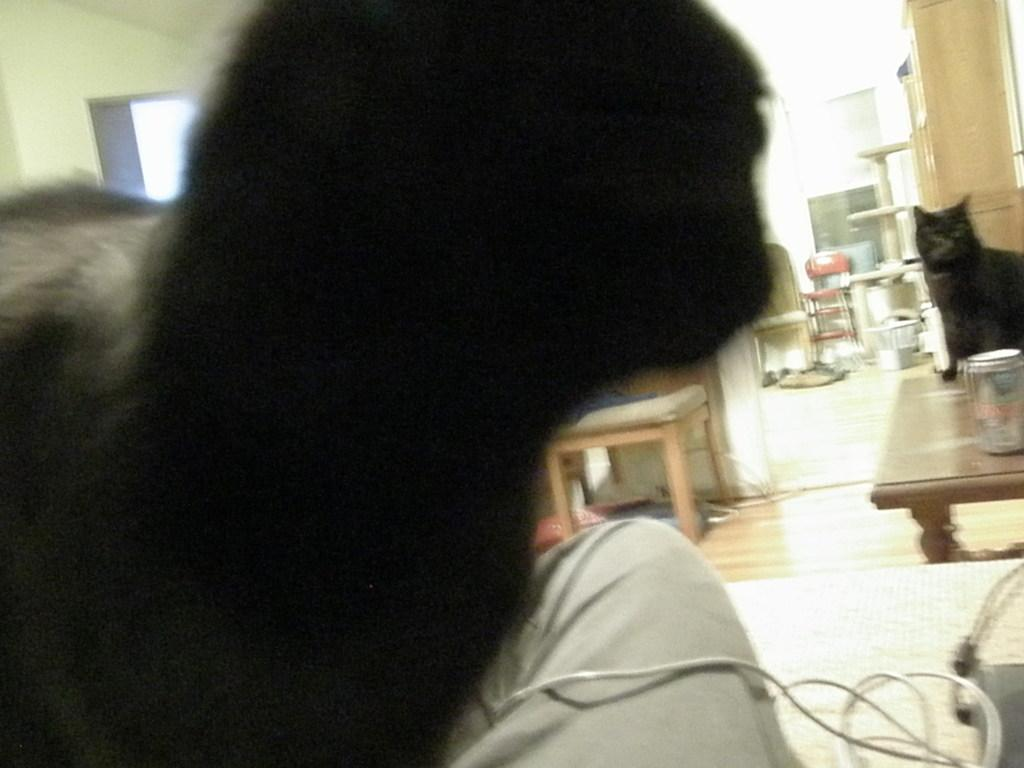What is on the floor in the image? There is a table on the floor in the image. What is on the table? There is a cat and a tin on the table. What can be seen in the background of the image? There is a chair in the background. Are there any objects near the table? Yes, there are objects on the table or nearby. What is visible on the wall in the image? There is a wall visible in the image. Can you describe the person in the image? There is a person with hair in the image. What type of peace is being promoted by the bee in the image? There is no bee present in the image, so it is not possible to answer that question. 